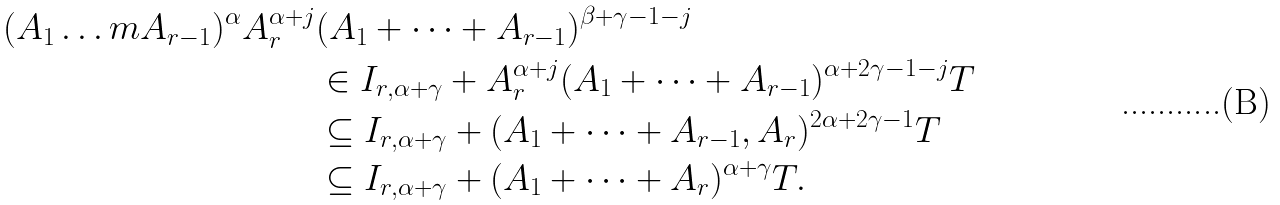Convert formula to latex. <formula><loc_0><loc_0><loc_500><loc_500>( A _ { 1 } \dots m A _ { r - 1 } ) ^ { \alpha } A _ { r } ^ { \alpha + j } & ( A _ { 1 } + \dots + A _ { r - 1 } ) ^ { \beta + \gamma - 1 - j } \\ & \in I _ { r , \alpha + \gamma } + A _ { r } ^ { \alpha + j } ( A _ { 1 } + \dots + A _ { r - 1 } ) ^ { \alpha + 2 \gamma - 1 - j } T \\ & \subseteq I _ { r , \alpha + \gamma } + ( A _ { 1 } + \dots + A _ { r - 1 } , A _ { r } ) ^ { 2 \alpha + 2 \gamma - 1 } T \\ & \subseteq I _ { r , \alpha + \gamma } + ( A _ { 1 } + \dots + A _ { r } ) ^ { \alpha + \gamma } T .</formula> 